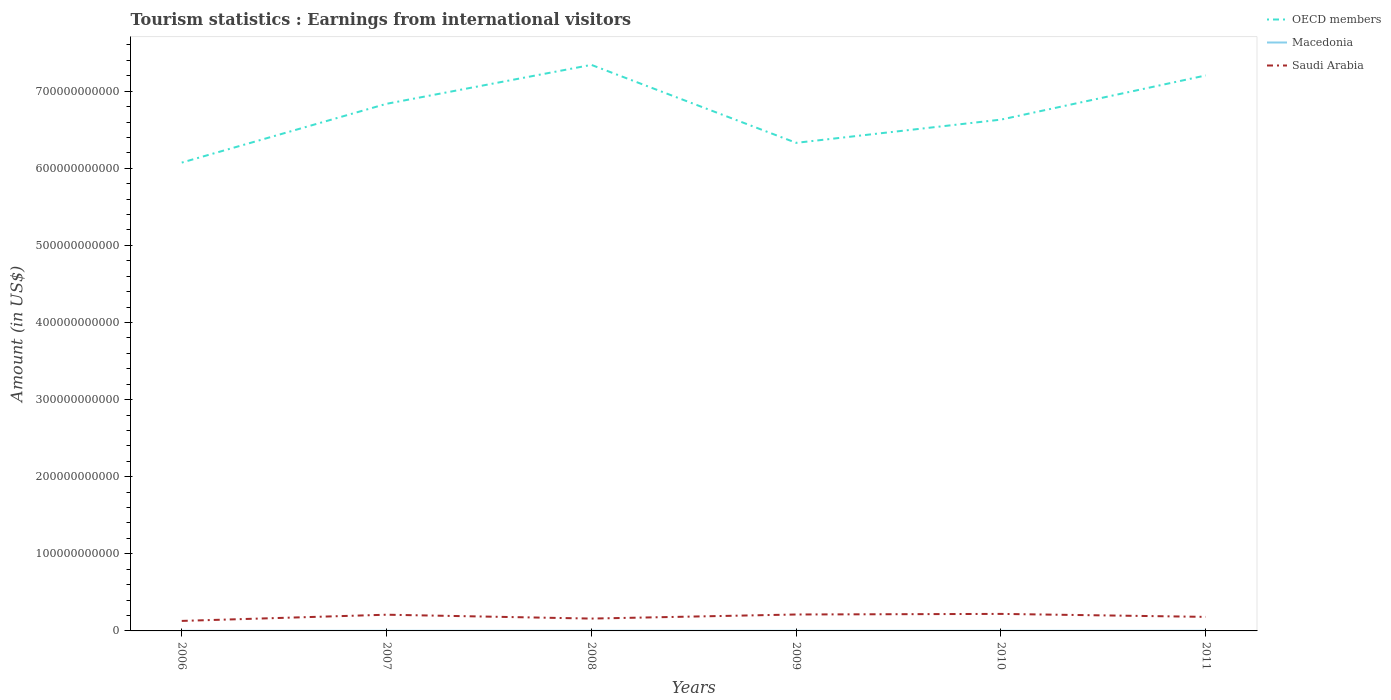How many different coloured lines are there?
Make the answer very short. 3. Across all years, what is the maximum earnings from international visitors in Macedonia?
Make the answer very short. 1.10e+08. In which year was the earnings from international visitors in Saudi Arabia maximum?
Offer a terse response. 2006. What is the total earnings from international visitors in Macedonia in the graph?
Keep it short and to the point. 9.00e+06. What is the difference between the highest and the second highest earnings from international visitors in OECD members?
Provide a succinct answer. 1.27e+11. What is the difference between the highest and the lowest earnings from international visitors in OECD members?
Give a very brief answer. 3. How many lines are there?
Keep it short and to the point. 3. How many years are there in the graph?
Your answer should be compact. 6. What is the difference between two consecutive major ticks on the Y-axis?
Provide a short and direct response. 1.00e+11. Does the graph contain any zero values?
Offer a very short reply. No. Does the graph contain grids?
Offer a terse response. No. How many legend labels are there?
Your answer should be compact. 3. How are the legend labels stacked?
Your answer should be compact. Vertical. What is the title of the graph?
Your response must be concise. Tourism statistics : Earnings from international visitors. Does "Poland" appear as one of the legend labels in the graph?
Your answer should be very brief. No. What is the Amount (in US$) of OECD members in 2006?
Provide a succinct answer. 6.07e+11. What is the Amount (in US$) of Macedonia in 2006?
Your response must be concise. 1.10e+08. What is the Amount (in US$) in Saudi Arabia in 2006?
Offer a terse response. 1.30e+1. What is the Amount (in US$) in OECD members in 2007?
Make the answer very short. 6.84e+11. What is the Amount (in US$) of Macedonia in 2007?
Make the answer very short. 1.47e+08. What is the Amount (in US$) in Saudi Arabia in 2007?
Offer a very short reply. 2.10e+1. What is the Amount (in US$) of OECD members in 2008?
Provide a succinct answer. 7.34e+11. What is the Amount (in US$) in Macedonia in 2008?
Make the answer very short. 1.90e+08. What is the Amount (in US$) of Saudi Arabia in 2008?
Offer a terse response. 1.60e+1. What is the Amount (in US$) in OECD members in 2009?
Keep it short and to the point. 6.33e+11. What is the Amount (in US$) in Macedonia in 2009?
Provide a short and direct response. 1.50e+08. What is the Amount (in US$) of Saudi Arabia in 2009?
Provide a succinct answer. 2.13e+1. What is the Amount (in US$) in OECD members in 2010?
Offer a very short reply. 6.63e+11. What is the Amount (in US$) of Macedonia in 2010?
Keep it short and to the point. 1.41e+08. What is the Amount (in US$) of Saudi Arabia in 2010?
Ensure brevity in your answer.  2.21e+1. What is the Amount (in US$) in OECD members in 2011?
Keep it short and to the point. 7.20e+11. What is the Amount (in US$) in Macedonia in 2011?
Keep it short and to the point. 1.59e+08. What is the Amount (in US$) of Saudi Arabia in 2011?
Provide a succinct answer. 1.82e+1. Across all years, what is the maximum Amount (in US$) of OECD members?
Provide a succinct answer. 7.34e+11. Across all years, what is the maximum Amount (in US$) in Macedonia?
Ensure brevity in your answer.  1.90e+08. Across all years, what is the maximum Amount (in US$) of Saudi Arabia?
Provide a succinct answer. 2.21e+1. Across all years, what is the minimum Amount (in US$) in OECD members?
Keep it short and to the point. 6.07e+11. Across all years, what is the minimum Amount (in US$) of Macedonia?
Provide a succinct answer. 1.10e+08. Across all years, what is the minimum Amount (in US$) of Saudi Arabia?
Your answer should be compact. 1.30e+1. What is the total Amount (in US$) in OECD members in the graph?
Provide a short and direct response. 4.04e+12. What is the total Amount (in US$) of Macedonia in the graph?
Keep it short and to the point. 8.97e+08. What is the total Amount (in US$) in Saudi Arabia in the graph?
Provide a succinct answer. 1.12e+11. What is the difference between the Amount (in US$) in OECD members in 2006 and that in 2007?
Your answer should be compact. -7.63e+1. What is the difference between the Amount (in US$) in Macedonia in 2006 and that in 2007?
Keep it short and to the point. -3.70e+07. What is the difference between the Amount (in US$) in Saudi Arabia in 2006 and that in 2007?
Offer a very short reply. -8.05e+09. What is the difference between the Amount (in US$) of OECD members in 2006 and that in 2008?
Provide a succinct answer. -1.27e+11. What is the difference between the Amount (in US$) in Macedonia in 2006 and that in 2008?
Your answer should be very brief. -8.00e+07. What is the difference between the Amount (in US$) in Saudi Arabia in 2006 and that in 2008?
Your answer should be compact. -3.03e+09. What is the difference between the Amount (in US$) of OECD members in 2006 and that in 2009?
Your answer should be compact. -2.56e+1. What is the difference between the Amount (in US$) in Macedonia in 2006 and that in 2009?
Keep it short and to the point. -4.00e+07. What is the difference between the Amount (in US$) of Saudi Arabia in 2006 and that in 2009?
Ensure brevity in your answer.  -8.33e+09. What is the difference between the Amount (in US$) of OECD members in 2006 and that in 2010?
Keep it short and to the point. -5.57e+1. What is the difference between the Amount (in US$) of Macedonia in 2006 and that in 2010?
Your response must be concise. -3.10e+07. What is the difference between the Amount (in US$) of Saudi Arabia in 2006 and that in 2010?
Your answer should be very brief. -9.10e+09. What is the difference between the Amount (in US$) of OECD members in 2006 and that in 2011?
Offer a terse response. -1.13e+11. What is the difference between the Amount (in US$) of Macedonia in 2006 and that in 2011?
Provide a short and direct response. -4.90e+07. What is the difference between the Amount (in US$) of Saudi Arabia in 2006 and that in 2011?
Offer a terse response. -5.22e+09. What is the difference between the Amount (in US$) of OECD members in 2007 and that in 2008?
Offer a very short reply. -5.05e+1. What is the difference between the Amount (in US$) in Macedonia in 2007 and that in 2008?
Provide a short and direct response. -4.30e+07. What is the difference between the Amount (in US$) of Saudi Arabia in 2007 and that in 2008?
Offer a terse response. 5.03e+09. What is the difference between the Amount (in US$) in OECD members in 2007 and that in 2009?
Make the answer very short. 5.06e+1. What is the difference between the Amount (in US$) of Saudi Arabia in 2007 and that in 2009?
Offer a very short reply. -2.81e+08. What is the difference between the Amount (in US$) in OECD members in 2007 and that in 2010?
Give a very brief answer. 2.05e+1. What is the difference between the Amount (in US$) in Saudi Arabia in 2007 and that in 2010?
Your answer should be compact. -1.04e+09. What is the difference between the Amount (in US$) in OECD members in 2007 and that in 2011?
Provide a succinct answer. -3.68e+1. What is the difference between the Amount (in US$) in Macedonia in 2007 and that in 2011?
Offer a terse response. -1.20e+07. What is the difference between the Amount (in US$) of Saudi Arabia in 2007 and that in 2011?
Ensure brevity in your answer.  2.83e+09. What is the difference between the Amount (in US$) in OECD members in 2008 and that in 2009?
Offer a very short reply. 1.01e+11. What is the difference between the Amount (in US$) of Macedonia in 2008 and that in 2009?
Make the answer very short. 4.00e+07. What is the difference between the Amount (in US$) of Saudi Arabia in 2008 and that in 2009?
Make the answer very short. -5.31e+09. What is the difference between the Amount (in US$) of OECD members in 2008 and that in 2010?
Keep it short and to the point. 7.10e+1. What is the difference between the Amount (in US$) of Macedonia in 2008 and that in 2010?
Provide a short and direct response. 4.90e+07. What is the difference between the Amount (in US$) of Saudi Arabia in 2008 and that in 2010?
Your answer should be compact. -6.07e+09. What is the difference between the Amount (in US$) in OECD members in 2008 and that in 2011?
Your response must be concise. 1.37e+1. What is the difference between the Amount (in US$) in Macedonia in 2008 and that in 2011?
Keep it short and to the point. 3.10e+07. What is the difference between the Amount (in US$) in Saudi Arabia in 2008 and that in 2011?
Your response must be concise. -2.20e+09. What is the difference between the Amount (in US$) in OECD members in 2009 and that in 2010?
Ensure brevity in your answer.  -3.01e+1. What is the difference between the Amount (in US$) in Macedonia in 2009 and that in 2010?
Your answer should be compact. 9.00e+06. What is the difference between the Amount (in US$) of Saudi Arabia in 2009 and that in 2010?
Your answer should be compact. -7.64e+08. What is the difference between the Amount (in US$) of OECD members in 2009 and that in 2011?
Keep it short and to the point. -8.74e+1. What is the difference between the Amount (in US$) in Macedonia in 2009 and that in 2011?
Your answer should be compact. -9.00e+06. What is the difference between the Amount (in US$) of Saudi Arabia in 2009 and that in 2011?
Provide a short and direct response. 3.11e+09. What is the difference between the Amount (in US$) in OECD members in 2010 and that in 2011?
Your answer should be very brief. -5.73e+1. What is the difference between the Amount (in US$) in Macedonia in 2010 and that in 2011?
Keep it short and to the point. -1.80e+07. What is the difference between the Amount (in US$) of Saudi Arabia in 2010 and that in 2011?
Give a very brief answer. 3.87e+09. What is the difference between the Amount (in US$) of OECD members in 2006 and the Amount (in US$) of Macedonia in 2007?
Ensure brevity in your answer.  6.07e+11. What is the difference between the Amount (in US$) of OECD members in 2006 and the Amount (in US$) of Saudi Arabia in 2007?
Your answer should be compact. 5.86e+11. What is the difference between the Amount (in US$) in Macedonia in 2006 and the Amount (in US$) in Saudi Arabia in 2007?
Your answer should be very brief. -2.09e+1. What is the difference between the Amount (in US$) of OECD members in 2006 and the Amount (in US$) of Macedonia in 2008?
Offer a very short reply. 6.07e+11. What is the difference between the Amount (in US$) of OECD members in 2006 and the Amount (in US$) of Saudi Arabia in 2008?
Give a very brief answer. 5.91e+11. What is the difference between the Amount (in US$) of Macedonia in 2006 and the Amount (in US$) of Saudi Arabia in 2008?
Ensure brevity in your answer.  -1.59e+1. What is the difference between the Amount (in US$) of OECD members in 2006 and the Amount (in US$) of Macedonia in 2009?
Keep it short and to the point. 6.07e+11. What is the difference between the Amount (in US$) of OECD members in 2006 and the Amount (in US$) of Saudi Arabia in 2009?
Ensure brevity in your answer.  5.86e+11. What is the difference between the Amount (in US$) in Macedonia in 2006 and the Amount (in US$) in Saudi Arabia in 2009?
Keep it short and to the point. -2.12e+1. What is the difference between the Amount (in US$) in OECD members in 2006 and the Amount (in US$) in Macedonia in 2010?
Provide a succinct answer. 6.07e+11. What is the difference between the Amount (in US$) of OECD members in 2006 and the Amount (in US$) of Saudi Arabia in 2010?
Provide a short and direct response. 5.85e+11. What is the difference between the Amount (in US$) in Macedonia in 2006 and the Amount (in US$) in Saudi Arabia in 2010?
Keep it short and to the point. -2.20e+1. What is the difference between the Amount (in US$) in OECD members in 2006 and the Amount (in US$) in Macedonia in 2011?
Make the answer very short. 6.07e+11. What is the difference between the Amount (in US$) in OECD members in 2006 and the Amount (in US$) in Saudi Arabia in 2011?
Make the answer very short. 5.89e+11. What is the difference between the Amount (in US$) in Macedonia in 2006 and the Amount (in US$) in Saudi Arabia in 2011?
Provide a succinct answer. -1.81e+1. What is the difference between the Amount (in US$) in OECD members in 2007 and the Amount (in US$) in Macedonia in 2008?
Your response must be concise. 6.83e+11. What is the difference between the Amount (in US$) of OECD members in 2007 and the Amount (in US$) of Saudi Arabia in 2008?
Keep it short and to the point. 6.68e+11. What is the difference between the Amount (in US$) of Macedonia in 2007 and the Amount (in US$) of Saudi Arabia in 2008?
Provide a short and direct response. -1.59e+1. What is the difference between the Amount (in US$) in OECD members in 2007 and the Amount (in US$) in Macedonia in 2009?
Ensure brevity in your answer.  6.83e+11. What is the difference between the Amount (in US$) in OECD members in 2007 and the Amount (in US$) in Saudi Arabia in 2009?
Provide a succinct answer. 6.62e+11. What is the difference between the Amount (in US$) in Macedonia in 2007 and the Amount (in US$) in Saudi Arabia in 2009?
Provide a succinct answer. -2.12e+1. What is the difference between the Amount (in US$) of OECD members in 2007 and the Amount (in US$) of Macedonia in 2010?
Offer a very short reply. 6.83e+11. What is the difference between the Amount (in US$) in OECD members in 2007 and the Amount (in US$) in Saudi Arabia in 2010?
Give a very brief answer. 6.62e+11. What is the difference between the Amount (in US$) of Macedonia in 2007 and the Amount (in US$) of Saudi Arabia in 2010?
Your response must be concise. -2.19e+1. What is the difference between the Amount (in US$) of OECD members in 2007 and the Amount (in US$) of Macedonia in 2011?
Make the answer very short. 6.83e+11. What is the difference between the Amount (in US$) of OECD members in 2007 and the Amount (in US$) of Saudi Arabia in 2011?
Your answer should be compact. 6.65e+11. What is the difference between the Amount (in US$) in Macedonia in 2007 and the Amount (in US$) in Saudi Arabia in 2011?
Ensure brevity in your answer.  -1.81e+1. What is the difference between the Amount (in US$) in OECD members in 2008 and the Amount (in US$) in Macedonia in 2009?
Provide a succinct answer. 7.34e+11. What is the difference between the Amount (in US$) in OECD members in 2008 and the Amount (in US$) in Saudi Arabia in 2009?
Offer a terse response. 7.13e+11. What is the difference between the Amount (in US$) in Macedonia in 2008 and the Amount (in US$) in Saudi Arabia in 2009?
Ensure brevity in your answer.  -2.11e+1. What is the difference between the Amount (in US$) in OECD members in 2008 and the Amount (in US$) in Macedonia in 2010?
Provide a short and direct response. 7.34e+11. What is the difference between the Amount (in US$) in OECD members in 2008 and the Amount (in US$) in Saudi Arabia in 2010?
Provide a succinct answer. 7.12e+11. What is the difference between the Amount (in US$) in Macedonia in 2008 and the Amount (in US$) in Saudi Arabia in 2010?
Provide a short and direct response. -2.19e+1. What is the difference between the Amount (in US$) of OECD members in 2008 and the Amount (in US$) of Macedonia in 2011?
Give a very brief answer. 7.34e+11. What is the difference between the Amount (in US$) of OECD members in 2008 and the Amount (in US$) of Saudi Arabia in 2011?
Make the answer very short. 7.16e+11. What is the difference between the Amount (in US$) in Macedonia in 2008 and the Amount (in US$) in Saudi Arabia in 2011?
Keep it short and to the point. -1.80e+1. What is the difference between the Amount (in US$) of OECD members in 2009 and the Amount (in US$) of Macedonia in 2010?
Give a very brief answer. 6.33e+11. What is the difference between the Amount (in US$) in OECD members in 2009 and the Amount (in US$) in Saudi Arabia in 2010?
Provide a short and direct response. 6.11e+11. What is the difference between the Amount (in US$) of Macedonia in 2009 and the Amount (in US$) of Saudi Arabia in 2010?
Give a very brief answer. -2.19e+1. What is the difference between the Amount (in US$) in OECD members in 2009 and the Amount (in US$) in Macedonia in 2011?
Make the answer very short. 6.33e+11. What is the difference between the Amount (in US$) in OECD members in 2009 and the Amount (in US$) in Saudi Arabia in 2011?
Your answer should be very brief. 6.15e+11. What is the difference between the Amount (in US$) in Macedonia in 2009 and the Amount (in US$) in Saudi Arabia in 2011?
Give a very brief answer. -1.81e+1. What is the difference between the Amount (in US$) of OECD members in 2010 and the Amount (in US$) of Macedonia in 2011?
Your answer should be very brief. 6.63e+11. What is the difference between the Amount (in US$) of OECD members in 2010 and the Amount (in US$) of Saudi Arabia in 2011?
Ensure brevity in your answer.  6.45e+11. What is the difference between the Amount (in US$) in Macedonia in 2010 and the Amount (in US$) in Saudi Arabia in 2011?
Your answer should be compact. -1.81e+1. What is the average Amount (in US$) in OECD members per year?
Provide a short and direct response. 6.74e+11. What is the average Amount (in US$) in Macedonia per year?
Your response must be concise. 1.50e+08. What is the average Amount (in US$) in Saudi Arabia per year?
Offer a very short reply. 1.86e+1. In the year 2006, what is the difference between the Amount (in US$) in OECD members and Amount (in US$) in Macedonia?
Your response must be concise. 6.07e+11. In the year 2006, what is the difference between the Amount (in US$) in OECD members and Amount (in US$) in Saudi Arabia?
Your response must be concise. 5.94e+11. In the year 2006, what is the difference between the Amount (in US$) of Macedonia and Amount (in US$) of Saudi Arabia?
Offer a terse response. -1.29e+1. In the year 2007, what is the difference between the Amount (in US$) in OECD members and Amount (in US$) in Macedonia?
Your answer should be very brief. 6.83e+11. In the year 2007, what is the difference between the Amount (in US$) in OECD members and Amount (in US$) in Saudi Arabia?
Make the answer very short. 6.63e+11. In the year 2007, what is the difference between the Amount (in US$) of Macedonia and Amount (in US$) of Saudi Arabia?
Your response must be concise. -2.09e+1. In the year 2008, what is the difference between the Amount (in US$) of OECD members and Amount (in US$) of Macedonia?
Give a very brief answer. 7.34e+11. In the year 2008, what is the difference between the Amount (in US$) in OECD members and Amount (in US$) in Saudi Arabia?
Offer a very short reply. 7.18e+11. In the year 2008, what is the difference between the Amount (in US$) of Macedonia and Amount (in US$) of Saudi Arabia?
Provide a succinct answer. -1.58e+1. In the year 2009, what is the difference between the Amount (in US$) of OECD members and Amount (in US$) of Macedonia?
Offer a very short reply. 6.33e+11. In the year 2009, what is the difference between the Amount (in US$) of OECD members and Amount (in US$) of Saudi Arabia?
Your answer should be very brief. 6.12e+11. In the year 2009, what is the difference between the Amount (in US$) in Macedonia and Amount (in US$) in Saudi Arabia?
Your answer should be compact. -2.12e+1. In the year 2010, what is the difference between the Amount (in US$) in OECD members and Amount (in US$) in Macedonia?
Your answer should be compact. 6.63e+11. In the year 2010, what is the difference between the Amount (in US$) in OECD members and Amount (in US$) in Saudi Arabia?
Your answer should be very brief. 6.41e+11. In the year 2010, what is the difference between the Amount (in US$) in Macedonia and Amount (in US$) in Saudi Arabia?
Provide a succinct answer. -2.19e+1. In the year 2011, what is the difference between the Amount (in US$) of OECD members and Amount (in US$) of Macedonia?
Your answer should be very brief. 7.20e+11. In the year 2011, what is the difference between the Amount (in US$) in OECD members and Amount (in US$) in Saudi Arabia?
Keep it short and to the point. 7.02e+11. In the year 2011, what is the difference between the Amount (in US$) in Macedonia and Amount (in US$) in Saudi Arabia?
Offer a terse response. -1.80e+1. What is the ratio of the Amount (in US$) in OECD members in 2006 to that in 2007?
Make the answer very short. 0.89. What is the ratio of the Amount (in US$) in Macedonia in 2006 to that in 2007?
Make the answer very short. 0.75. What is the ratio of the Amount (in US$) in Saudi Arabia in 2006 to that in 2007?
Your answer should be compact. 0.62. What is the ratio of the Amount (in US$) of OECD members in 2006 to that in 2008?
Offer a terse response. 0.83. What is the ratio of the Amount (in US$) in Macedonia in 2006 to that in 2008?
Your answer should be compact. 0.58. What is the ratio of the Amount (in US$) in Saudi Arabia in 2006 to that in 2008?
Keep it short and to the point. 0.81. What is the ratio of the Amount (in US$) of OECD members in 2006 to that in 2009?
Your answer should be compact. 0.96. What is the ratio of the Amount (in US$) in Macedonia in 2006 to that in 2009?
Make the answer very short. 0.73. What is the ratio of the Amount (in US$) in Saudi Arabia in 2006 to that in 2009?
Your answer should be very brief. 0.61. What is the ratio of the Amount (in US$) of OECD members in 2006 to that in 2010?
Your answer should be compact. 0.92. What is the ratio of the Amount (in US$) of Macedonia in 2006 to that in 2010?
Provide a short and direct response. 0.78. What is the ratio of the Amount (in US$) of Saudi Arabia in 2006 to that in 2010?
Provide a short and direct response. 0.59. What is the ratio of the Amount (in US$) of OECD members in 2006 to that in 2011?
Provide a short and direct response. 0.84. What is the ratio of the Amount (in US$) of Macedonia in 2006 to that in 2011?
Offer a very short reply. 0.69. What is the ratio of the Amount (in US$) of Saudi Arabia in 2006 to that in 2011?
Your answer should be compact. 0.71. What is the ratio of the Amount (in US$) in OECD members in 2007 to that in 2008?
Ensure brevity in your answer.  0.93. What is the ratio of the Amount (in US$) of Macedonia in 2007 to that in 2008?
Keep it short and to the point. 0.77. What is the ratio of the Amount (in US$) in Saudi Arabia in 2007 to that in 2008?
Your answer should be compact. 1.31. What is the ratio of the Amount (in US$) of Saudi Arabia in 2007 to that in 2009?
Make the answer very short. 0.99. What is the ratio of the Amount (in US$) in OECD members in 2007 to that in 2010?
Offer a very short reply. 1.03. What is the ratio of the Amount (in US$) of Macedonia in 2007 to that in 2010?
Your answer should be very brief. 1.04. What is the ratio of the Amount (in US$) in Saudi Arabia in 2007 to that in 2010?
Make the answer very short. 0.95. What is the ratio of the Amount (in US$) of OECD members in 2007 to that in 2011?
Your answer should be compact. 0.95. What is the ratio of the Amount (in US$) of Macedonia in 2007 to that in 2011?
Provide a succinct answer. 0.92. What is the ratio of the Amount (in US$) in Saudi Arabia in 2007 to that in 2011?
Make the answer very short. 1.16. What is the ratio of the Amount (in US$) in OECD members in 2008 to that in 2009?
Provide a succinct answer. 1.16. What is the ratio of the Amount (in US$) of Macedonia in 2008 to that in 2009?
Your answer should be very brief. 1.27. What is the ratio of the Amount (in US$) of Saudi Arabia in 2008 to that in 2009?
Ensure brevity in your answer.  0.75. What is the ratio of the Amount (in US$) of OECD members in 2008 to that in 2010?
Offer a terse response. 1.11. What is the ratio of the Amount (in US$) in Macedonia in 2008 to that in 2010?
Your response must be concise. 1.35. What is the ratio of the Amount (in US$) of Saudi Arabia in 2008 to that in 2010?
Offer a terse response. 0.72. What is the ratio of the Amount (in US$) in OECD members in 2008 to that in 2011?
Provide a succinct answer. 1.02. What is the ratio of the Amount (in US$) of Macedonia in 2008 to that in 2011?
Give a very brief answer. 1.2. What is the ratio of the Amount (in US$) in Saudi Arabia in 2008 to that in 2011?
Your answer should be very brief. 0.88. What is the ratio of the Amount (in US$) in OECD members in 2009 to that in 2010?
Ensure brevity in your answer.  0.95. What is the ratio of the Amount (in US$) in Macedonia in 2009 to that in 2010?
Provide a succinct answer. 1.06. What is the ratio of the Amount (in US$) of Saudi Arabia in 2009 to that in 2010?
Keep it short and to the point. 0.97. What is the ratio of the Amount (in US$) in OECD members in 2009 to that in 2011?
Provide a succinct answer. 0.88. What is the ratio of the Amount (in US$) of Macedonia in 2009 to that in 2011?
Your answer should be compact. 0.94. What is the ratio of the Amount (in US$) of Saudi Arabia in 2009 to that in 2011?
Your answer should be compact. 1.17. What is the ratio of the Amount (in US$) in OECD members in 2010 to that in 2011?
Your answer should be compact. 0.92. What is the ratio of the Amount (in US$) in Macedonia in 2010 to that in 2011?
Your answer should be very brief. 0.89. What is the ratio of the Amount (in US$) of Saudi Arabia in 2010 to that in 2011?
Offer a terse response. 1.21. What is the difference between the highest and the second highest Amount (in US$) in OECD members?
Offer a terse response. 1.37e+1. What is the difference between the highest and the second highest Amount (in US$) in Macedonia?
Your answer should be compact. 3.10e+07. What is the difference between the highest and the second highest Amount (in US$) of Saudi Arabia?
Your answer should be very brief. 7.64e+08. What is the difference between the highest and the lowest Amount (in US$) in OECD members?
Your answer should be very brief. 1.27e+11. What is the difference between the highest and the lowest Amount (in US$) of Macedonia?
Provide a succinct answer. 8.00e+07. What is the difference between the highest and the lowest Amount (in US$) of Saudi Arabia?
Give a very brief answer. 9.10e+09. 